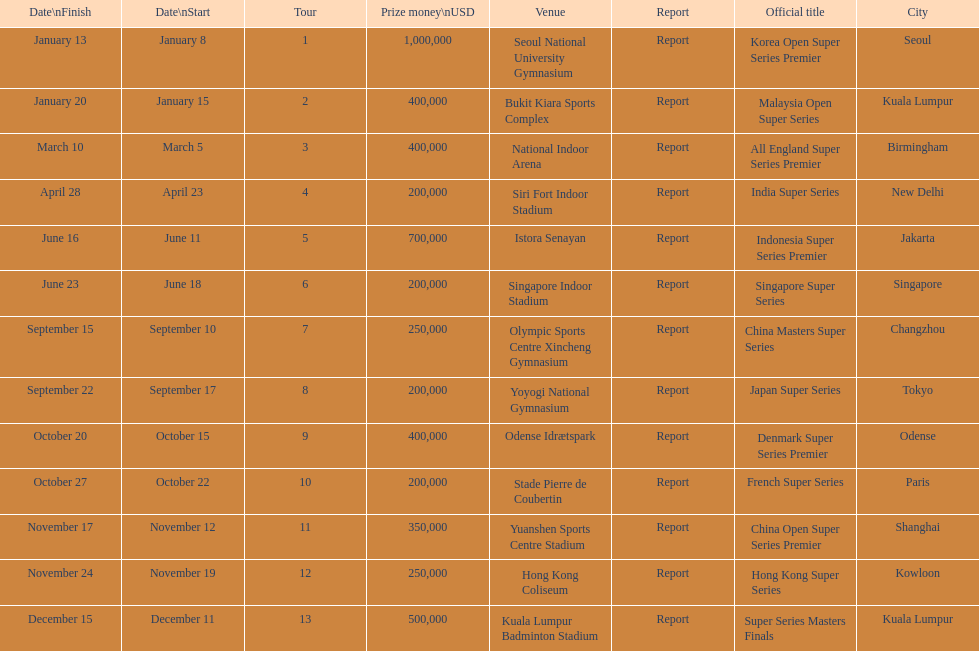What were the titles of the 2013 bwf super series? Korea Open Super Series Premier, Malaysia Open Super Series, All England Super Series Premier, India Super Series, Indonesia Super Series Premier, Singapore Super Series, China Masters Super Series, Japan Super Series, Denmark Super Series Premier, French Super Series, China Open Super Series Premier, Hong Kong Super Series, Super Series Masters Finals. Which were in december? Super Series Masters Finals. 